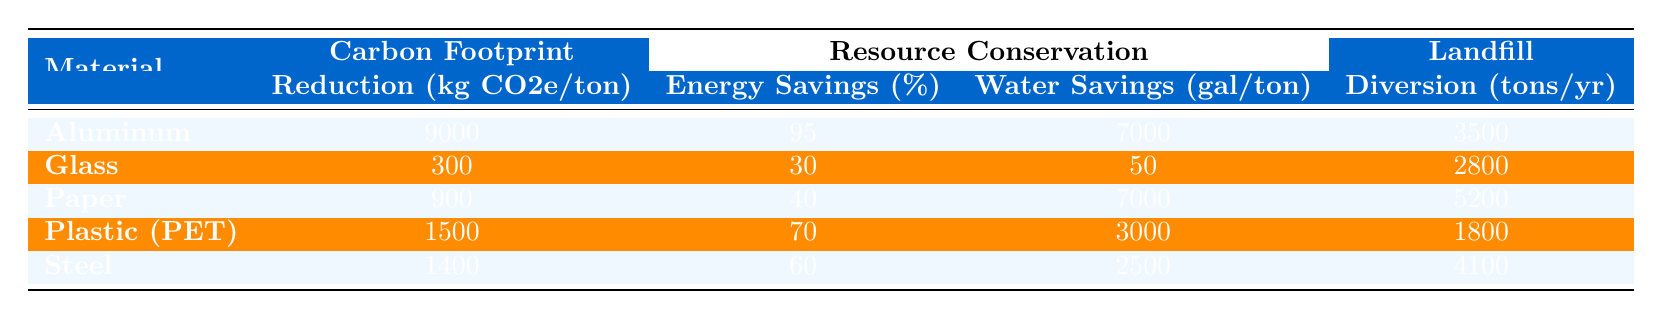What is the carbon footprint reduction for Aluminum? The table shows that Aluminum has a carbon footprint reduction of 9000 kg CO2e/ton.
Answer: 9000 kg CO2e/ton Which material has the highest water savings per ton? According to the table, both Aluminum and Paper have the highest water savings of 7000 gallons/ton, which is the maximum listed.
Answer: Aluminum and Paper How many tons of Steel are diverted from landfills annually? The table indicates that Steel has a landfill diversion of 4100 tons/year.
Answer: 4100 tons/year What is the average carbon footprint reduction of all materials listed? To find the average, sum the carbon footprint reductions: 9000 + 300 + 900 + 1500 + 1400 = 13100. Then divide by the number of materials (5): 13100 / 5 = 2620.
Answer: 2620 kg CO2e/ton Is the average energy savings of plastics (PET) higher than 50%? The energy savings for Plastic (PET) is 70%, which is greater than 50%. Hence, the statement is true.
Answer: Yes Which material has the lowest carbon footprint reduction? By examining the table, Glass has the lowest carbon footprint reduction at 300 kg CO2e/ton.
Answer: Glass What is the combined landfill diversion for Paper and Plastic (PET) materials? Adding the landfill diversions for Paper (5200 tons/year) and Plastic (PET) (1800 tons/year): 5200 + 1800 = 7000 tons/year.
Answer: 7000 tons/year Which material, on average, conserves more water, Aluminum or Steel? Aluminum conserves 7000 gallons/ton while Steel conserves 2500 gallons/ton; therefore, Aluminum conserves more water.
Answer: Aluminum If we consider the materials listed, which one shows the greatest resource conservation through energy savings? Aluminum shows the greatest resource conservation for energy savings, with 95%.
Answer: Aluminum Considering all materials, which one has the lowest water savings? The material with the lowest water savings is Glass, which saves only 50 gallons/ton.
Answer: Glass 